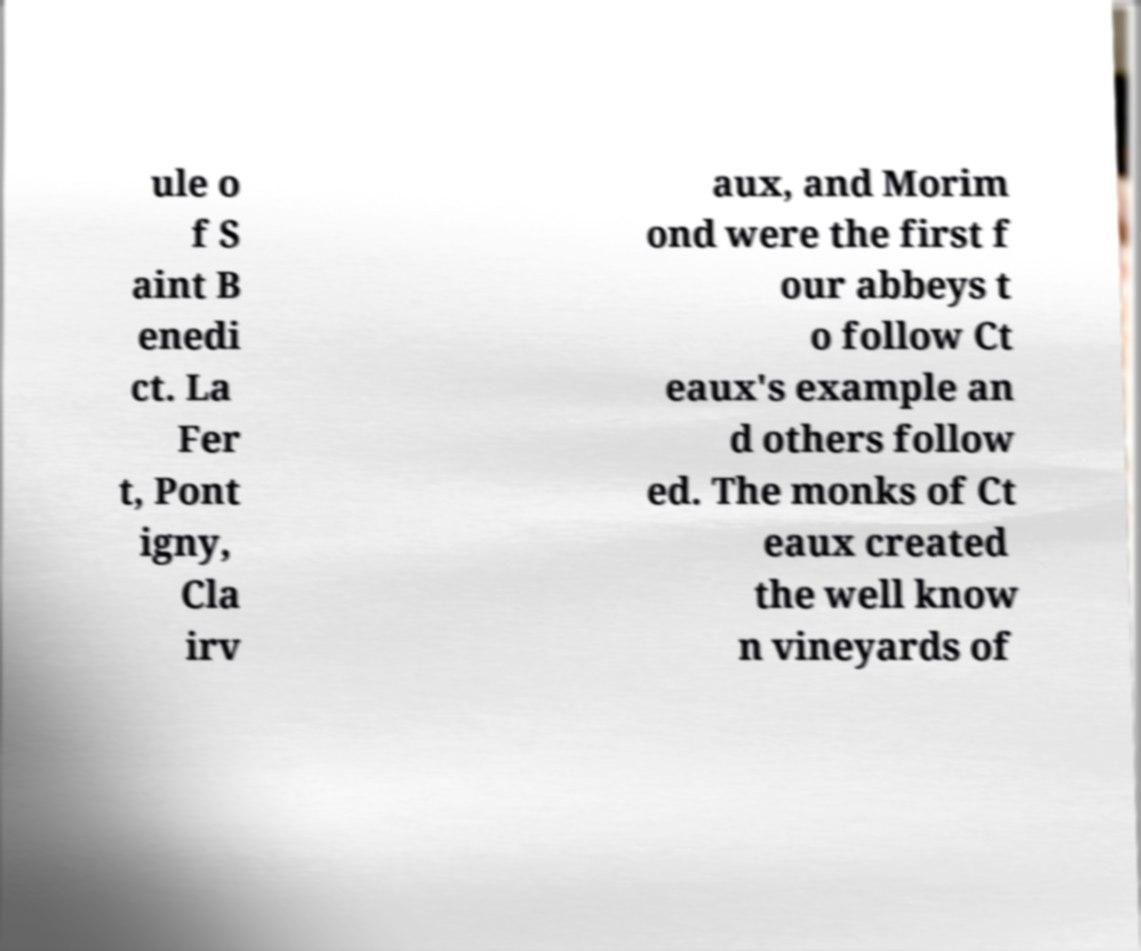There's text embedded in this image that I need extracted. Can you transcribe it verbatim? ule o f S aint B enedi ct. La Fer t, Pont igny, Cla irv aux, and Morim ond were the first f our abbeys t o follow Ct eaux's example an d others follow ed. The monks of Ct eaux created the well know n vineyards of 